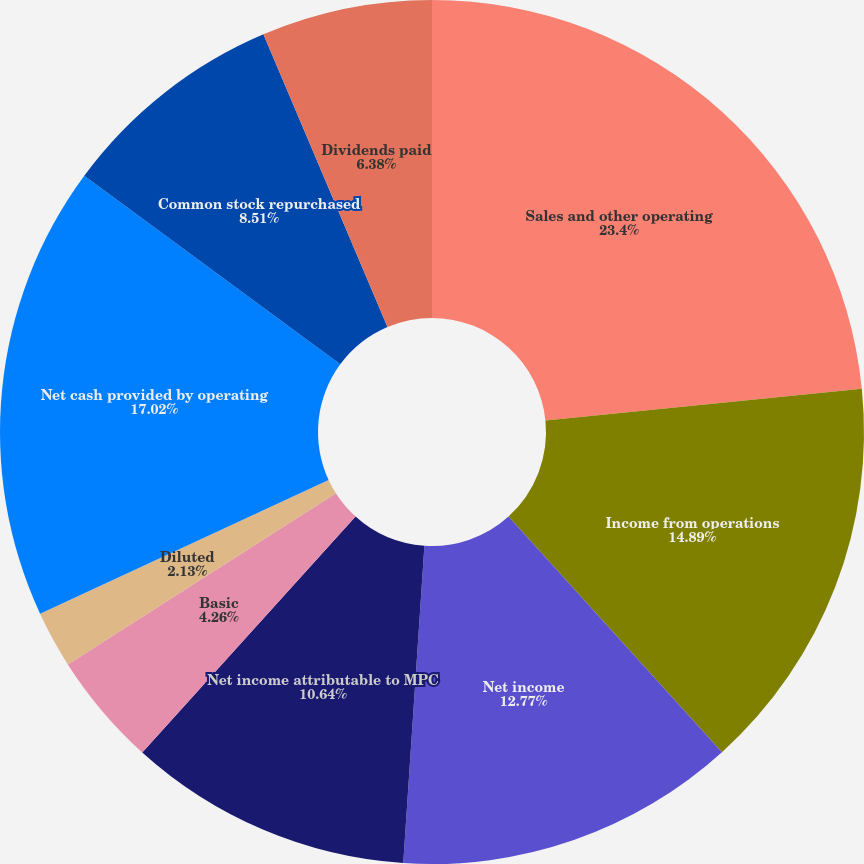Convert chart to OTSL. <chart><loc_0><loc_0><loc_500><loc_500><pie_chart><fcel>Sales and other operating<fcel>Income from operations<fcel>Net income<fcel>Net income attributable to MPC<fcel>Basic<fcel>Diluted<fcel>Dividends per share<fcel>Net cash provided by operating<fcel>Common stock repurchased<fcel>Dividends paid<nl><fcel>23.4%<fcel>14.89%<fcel>12.77%<fcel>10.64%<fcel>4.26%<fcel>2.13%<fcel>0.0%<fcel>17.02%<fcel>8.51%<fcel>6.38%<nl></chart> 